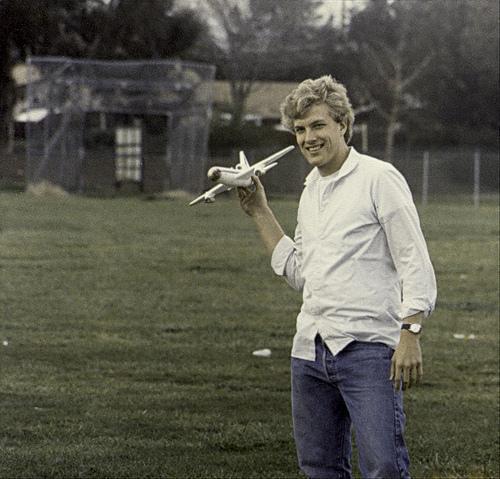How many men are there?
Give a very brief answer. 1. 